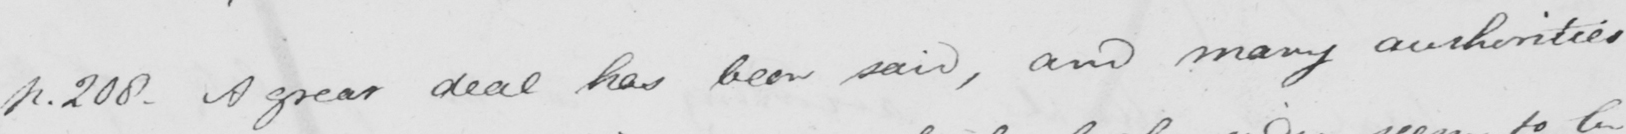What is written in this line of handwriting? p . 208 . A great deal has been said , and many authorities 